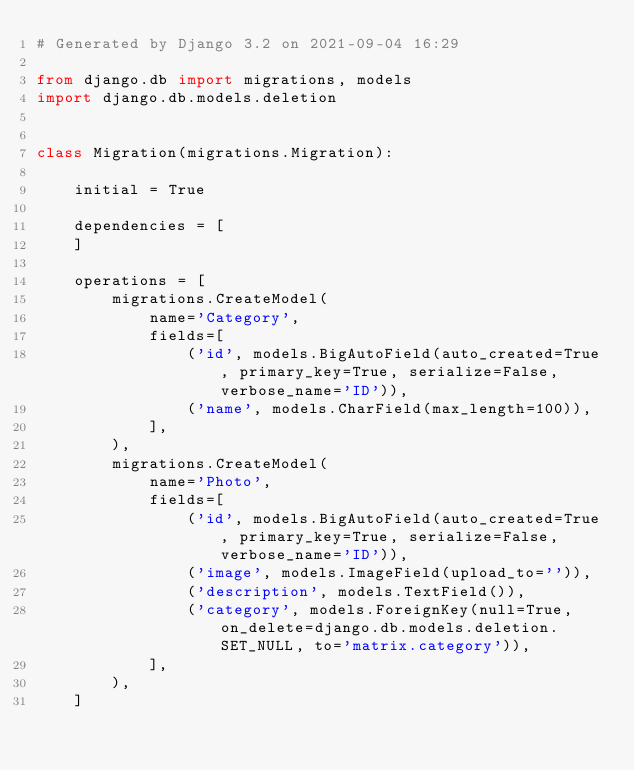Convert code to text. <code><loc_0><loc_0><loc_500><loc_500><_Python_># Generated by Django 3.2 on 2021-09-04 16:29

from django.db import migrations, models
import django.db.models.deletion


class Migration(migrations.Migration):

    initial = True

    dependencies = [
    ]

    operations = [
        migrations.CreateModel(
            name='Category',
            fields=[
                ('id', models.BigAutoField(auto_created=True, primary_key=True, serialize=False, verbose_name='ID')),
                ('name', models.CharField(max_length=100)),
            ],
        ),
        migrations.CreateModel(
            name='Photo',
            fields=[
                ('id', models.BigAutoField(auto_created=True, primary_key=True, serialize=False, verbose_name='ID')),
                ('image', models.ImageField(upload_to='')),
                ('description', models.TextField()),
                ('category', models.ForeignKey(null=True, on_delete=django.db.models.deletion.SET_NULL, to='matrix.category')),
            ],
        ),
    ]
</code> 